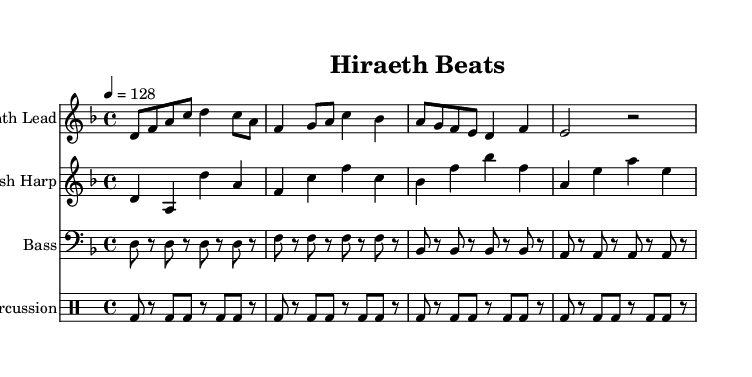What is the key signature of this music? The key signature is indicated at the beginning of the score and shows two flats, which corresponds to D minor.
Answer: D minor What is the time signature of this music? The time signature is shown at the beginning of the score, showing a fraction with a 4 on top and a 4 on the bottom, which represents four beats per measure.
Answer: 4/4 What is the indicated tempo for this piece? The tempo marking is found near the beginning of the score, showing a quarter note equals 128 beats per minute, which sets the speed of the piece.
Answer: 128 How many measures are in the synth lead? By counting each segment in the synth lead section, we can see that there are a total of four measures present.
Answer: 4 Which instrument plays the traditional Welsh element? The instrument specifically indicated for traditional sound, often associated with Welsh music, is outlined in the score and is referred to as the "Welsh Harp."
Answer: Welsh Harp What rhythmic pattern is used for the percussion? The percussion section is represented in a drummode with a specific pattern of bass drum hits and rests, which showcases a consistent eighth-note rhythmic structure across the measures.
Answer: Eighth-note pattern How does the bass line relate to the rhythm of the synth lead? An analysis of both the bass and synth lead sections reveals the bass line plays a steady rhythm with eighth notes that support the more melodic and syncopated rhythm in the synth lead.
Answer: Steady supportive rhythm 